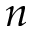Convert formula to latex. <formula><loc_0><loc_0><loc_500><loc_500>n</formula> 